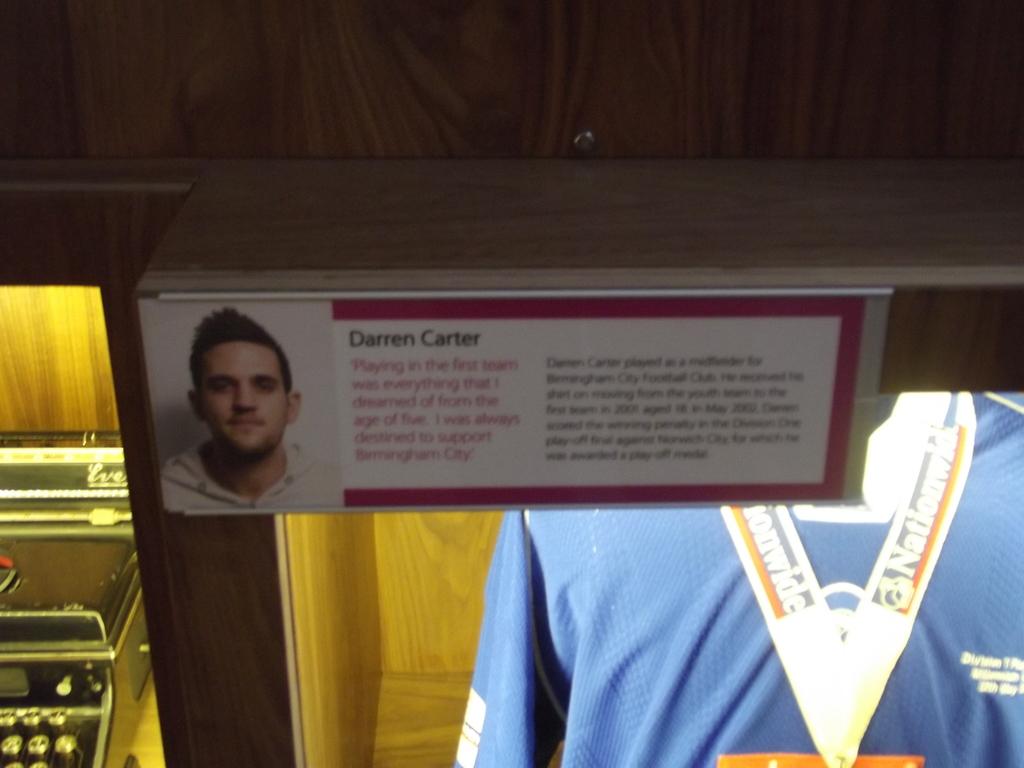Is darren carter a professional sports player?
Give a very brief answer. Yes. 